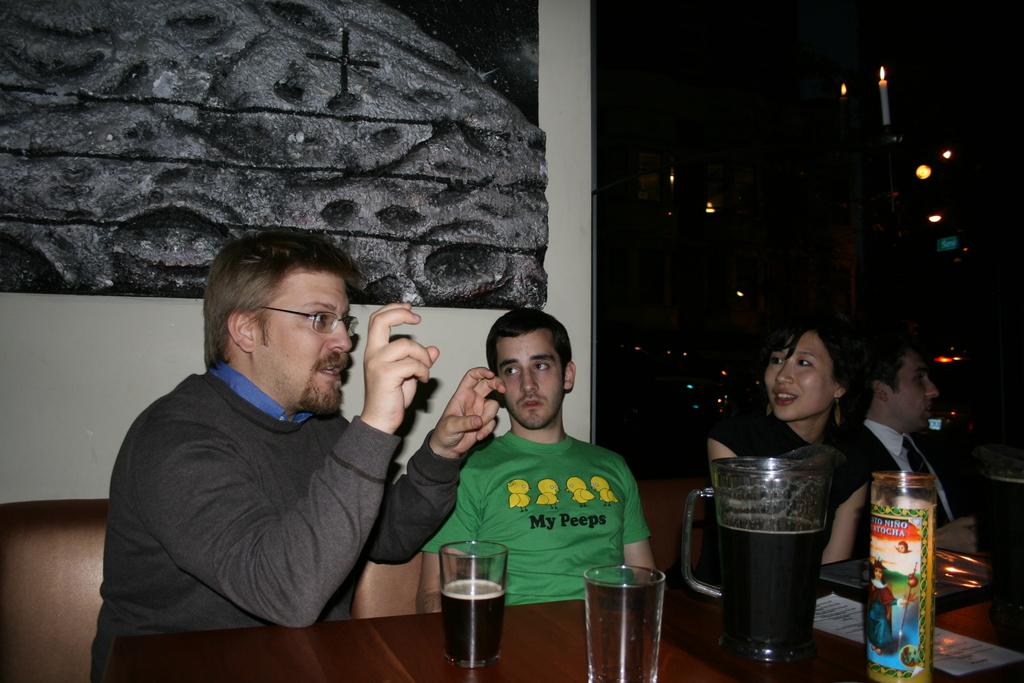What is written on the man's green shirt?
Offer a very short reply. My peeps. 